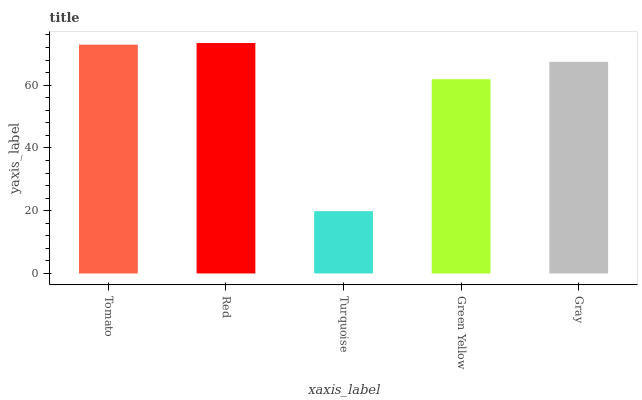Is Turquoise the minimum?
Answer yes or no. Yes. Is Red the maximum?
Answer yes or no. Yes. Is Red the minimum?
Answer yes or no. No. Is Turquoise the maximum?
Answer yes or no. No. Is Red greater than Turquoise?
Answer yes or no. Yes. Is Turquoise less than Red?
Answer yes or no. Yes. Is Turquoise greater than Red?
Answer yes or no. No. Is Red less than Turquoise?
Answer yes or no. No. Is Gray the high median?
Answer yes or no. Yes. Is Gray the low median?
Answer yes or no. Yes. Is Green Yellow the high median?
Answer yes or no. No. Is Green Yellow the low median?
Answer yes or no. No. 